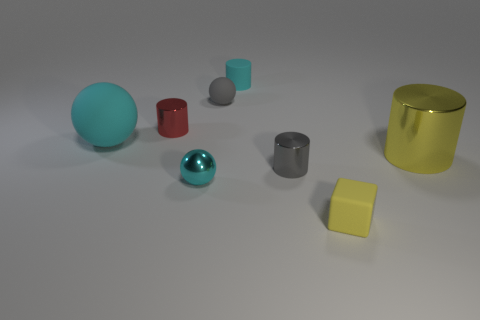Does the rubber cylinder have the same color as the matte sphere on the left side of the metal ball?
Give a very brief answer. Yes. There is a small shiny cylinder on the right side of the tiny ball that is in front of the red metal cylinder; what color is it?
Your answer should be very brief. Gray. There is a yellow block that is in front of the yellow object that is behind the tiny yellow rubber cube; are there any spheres on the right side of it?
Your response must be concise. No. There is a ball that is made of the same material as the red cylinder; what color is it?
Make the answer very short. Cyan. Is the big cyan ball made of the same material as the small gray object that is behind the large cylinder?
Give a very brief answer. Yes. How big is the yellow thing to the right of the tiny rubber cube that is to the right of the small cylinder that is behind the tiny gray ball?
Keep it short and to the point. Large. There is a cylinder that is the same color as the small block; what is its material?
Provide a succinct answer. Metal. There is a cyan ball that is in front of the cylinder that is to the right of the small gray metallic thing; what size is it?
Give a very brief answer. Small. Is the color of the small matte cylinder the same as the small cube?
Keep it short and to the point. No. There is a small ball that is in front of the tiny gray metallic cylinder; what number of tiny cylinders are in front of it?
Keep it short and to the point. 0. 